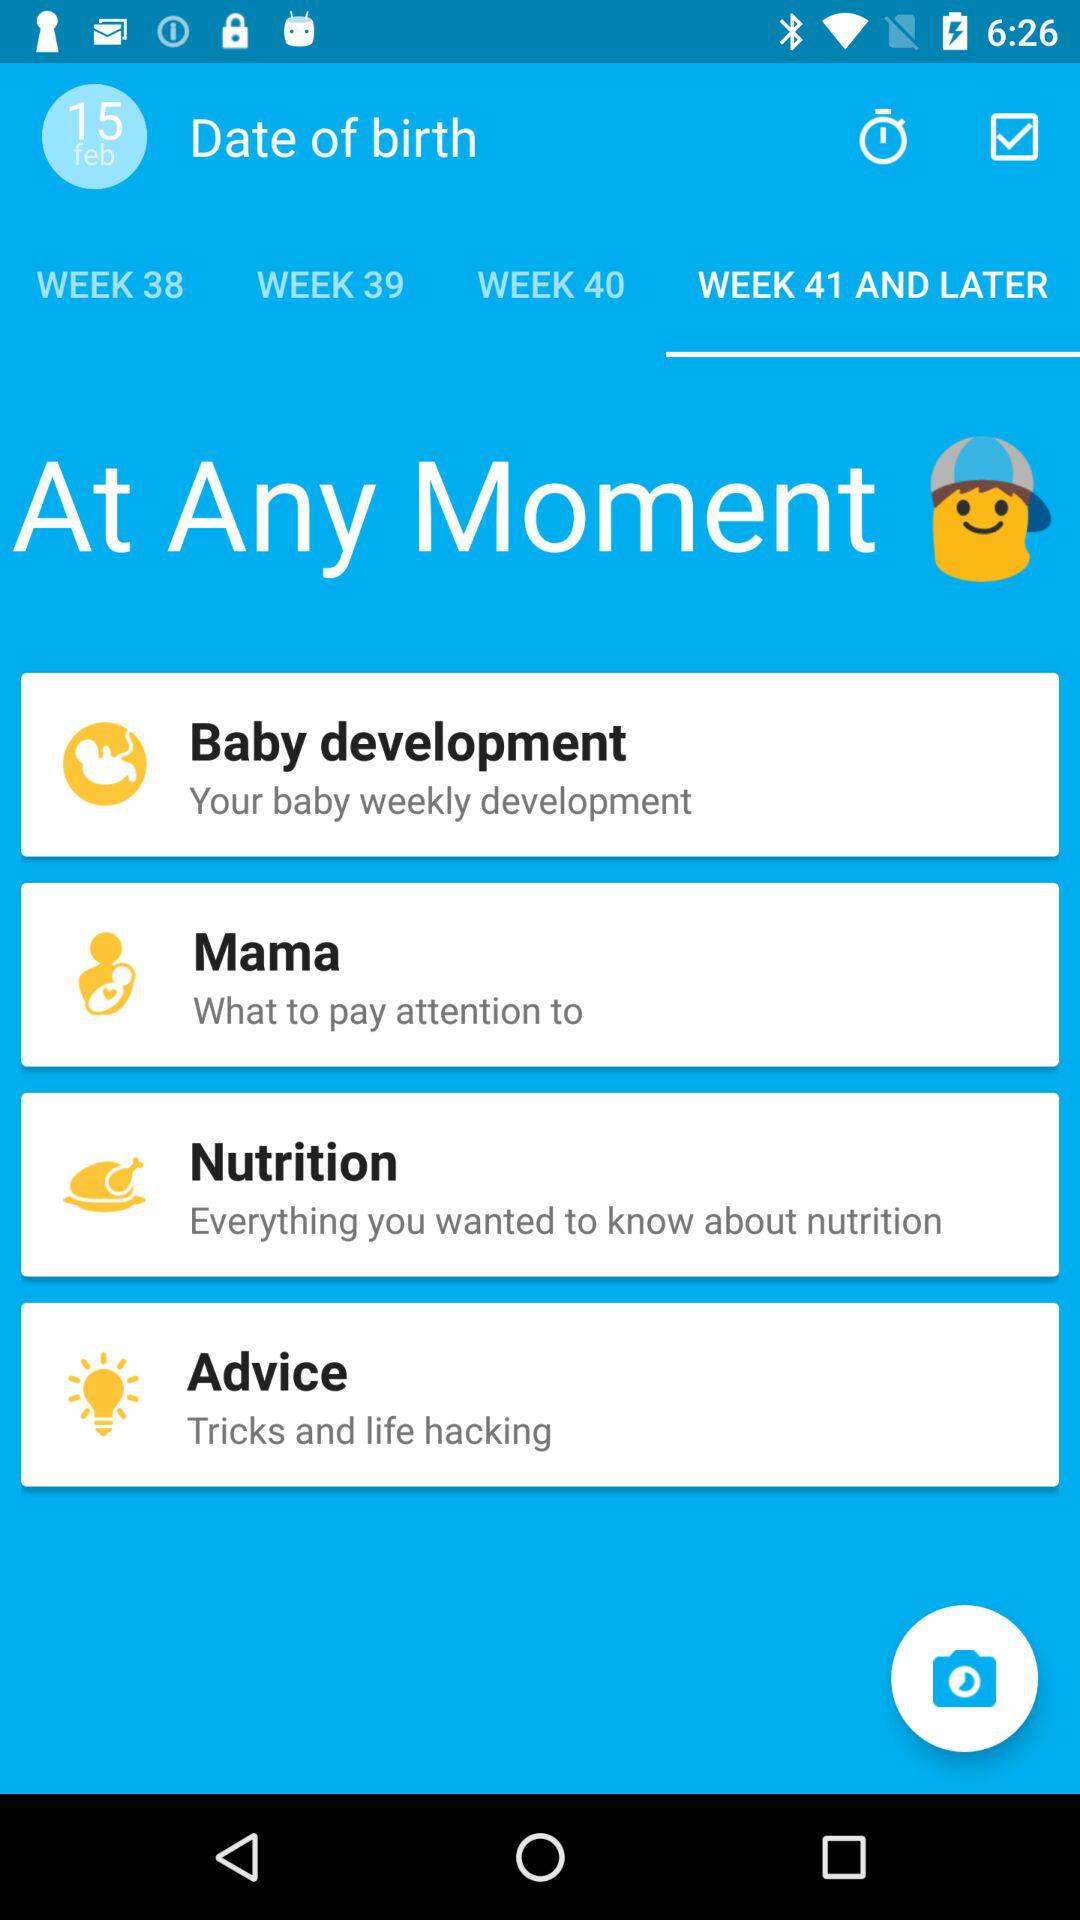How much does the baby weigh now?
When the provided information is insufficient, respond with <no answer>. <no answer> 